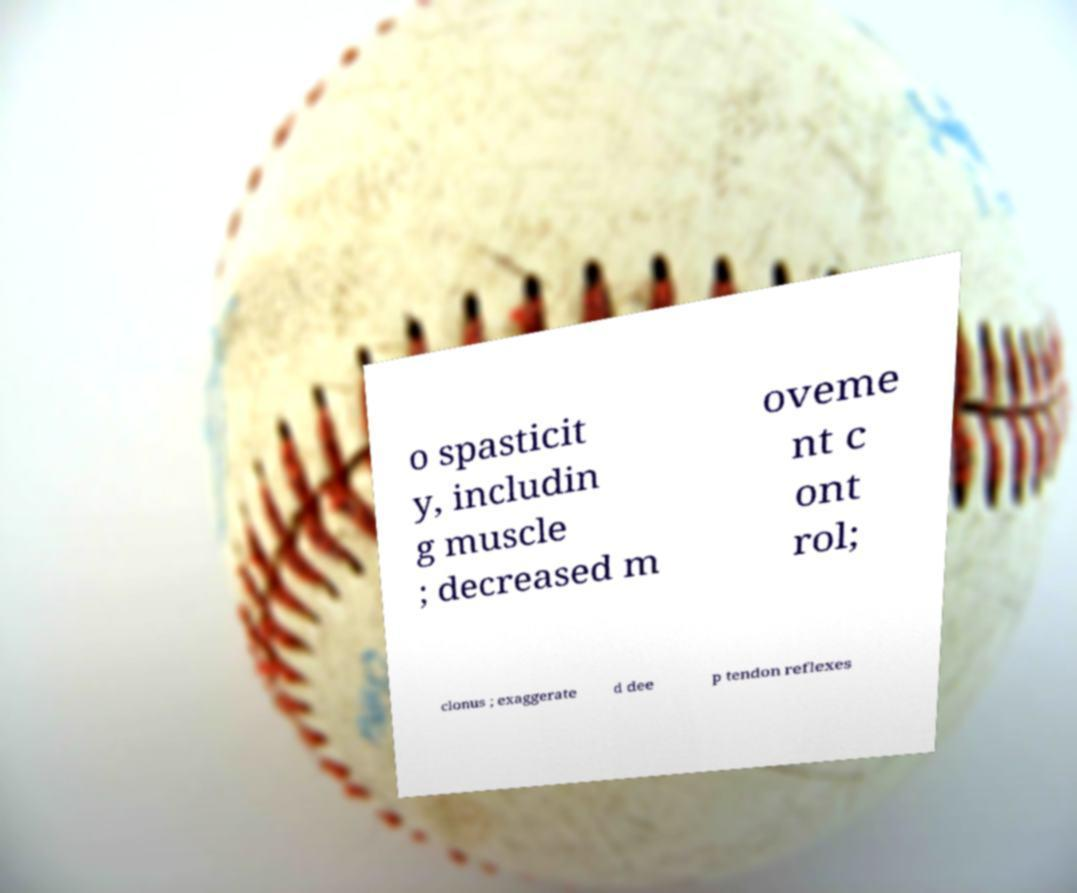Could you extract and type out the text from this image? o spasticit y, includin g muscle ; decreased m oveme nt c ont rol; clonus ; exaggerate d dee p tendon reflexes 